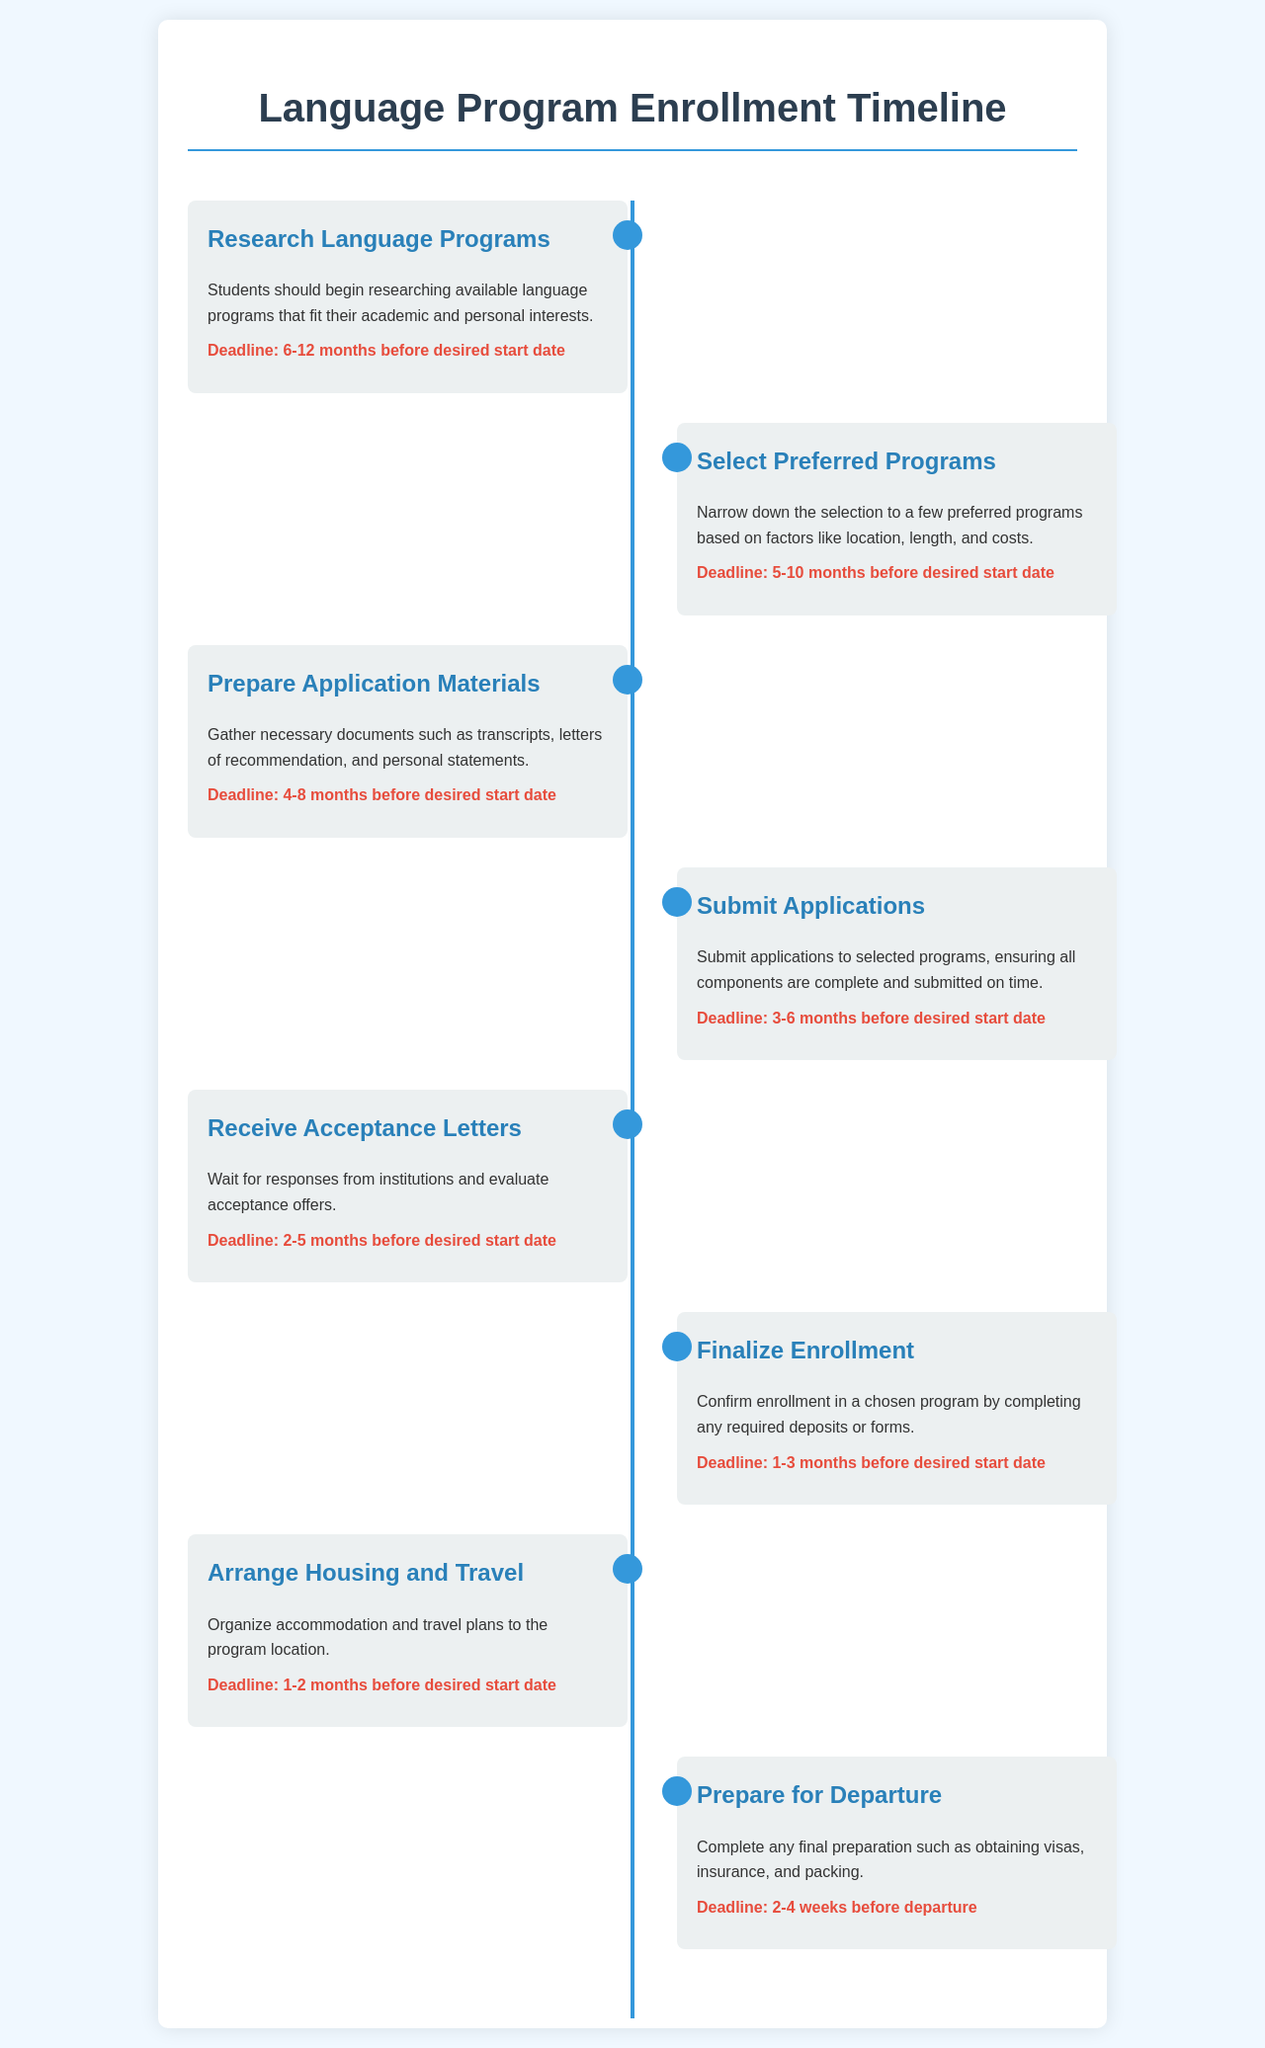What is the first milestone in the timeline? The first milestone in the timeline is "Research Language Programs," which is focused on beginning the research process.
Answer: Research Language Programs How many months before the desired start date should students submit their applications? Students should submit their applications 3-6 months before the desired start date.
Answer: 3-6 months What should students organize 1-2 months before the desired start date? Students should arrange housing and travel 1-2 months before the desired start date.
Answer: Arrange Housing and Travel When should application materials be prepared? Application materials should be prepared 4-8 months before the desired start date.
Answer: 4-8 months What is the specified deadline for finalizing enrollment? The specified deadline for finalizing enrollment is 1-3 months before the desired start date.
Answer: 1-3 months Which milestone involves obtaining visas? The milestone that involves obtaining visas is "Prepare for Departure."
Answer: Prepare for Departure How long before departure should students complete final preparations? Students should complete final preparations 2-4 weeks before departure.
Answer: 2-4 weeks What is the deadline for receiving acceptance letters? The deadline for receiving acceptance letters is 2-5 months before the desired start date.
Answer: 2-5 months How many steps are outlined in the enrollment timeline? The document outlines a total of 8 steps in the enrollment timeline.
Answer: 8 steps 